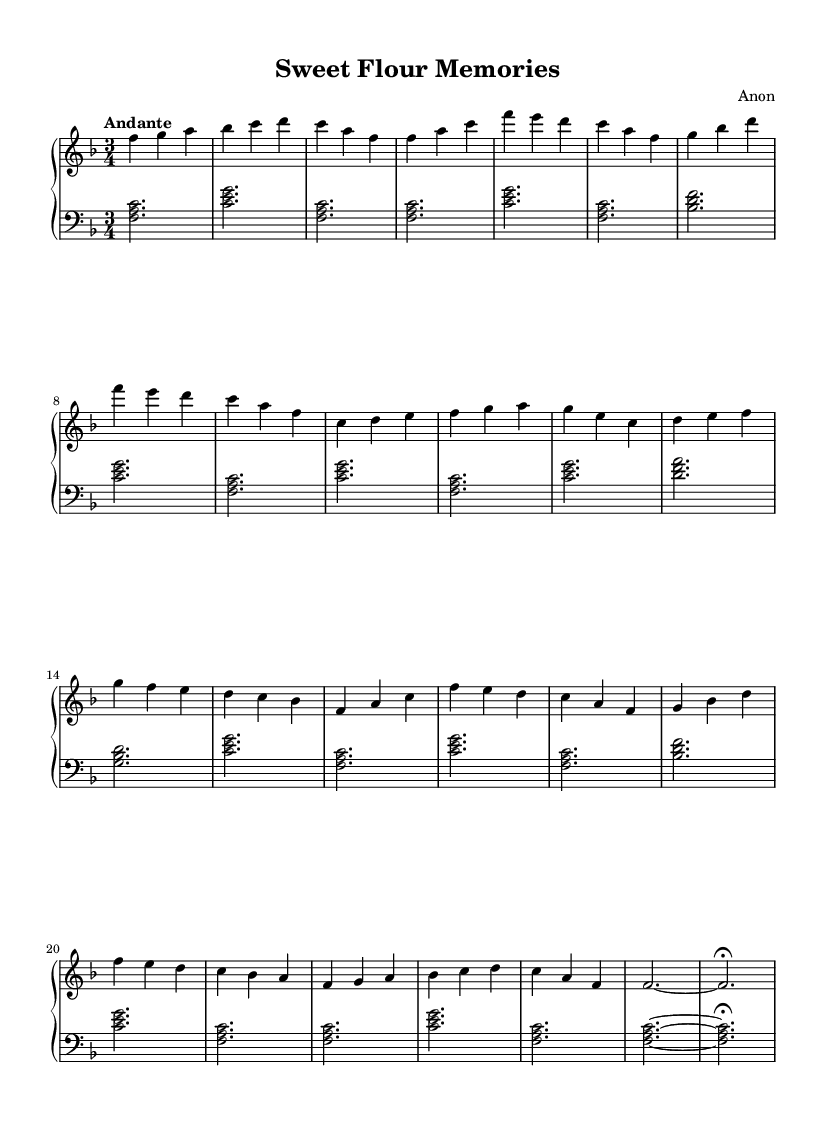What is the key signature of this music? The key signature is F major, which has one flat (B flat). This can be identified in the key signature indicated at the beginning of the sheet music, which shows the flat symbol.
Answer: F major What is the time signature of this music? The time signature is 3/4, which indicates that there are three beats per measure and a quarter note receives one beat. This is usually noted at the beginning of the sheet music, right after the key signature.
Answer: 3/4 What is the tempo marking of this piece? The tempo marking is "Andante," which typically implies a moderate pace. The word is also included in the tempo instruction at the start of the music.
Answer: Andante How many measures are in section A of the music? Section A consists of 8 measures. This can be counted by reviewing the corresponding notes from the start of section A until its end, tracking the measure borders.
Answer: 8 What is the last note of the piece? The last note of the piece is F. This can be observed in the final measure where the note is clearly marked just before the fermata.
Answer: F What is the chord played in the left hand during the introduction? The chord played is F major. This can be seen from the note combination shown in the left-hand part of the introduction, which includes the notes F, A, and C.
Answer: F major How many times is section B repeated in the music? Section B is repeated once, making two total appearances in the sheet music. This repetition can be verified by locating both instances labeled in the structure of the score.
Answer: Once 